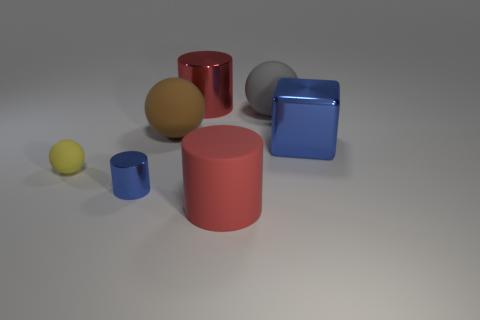There is a matte cylinder; how many small cylinders are behind it?
Your answer should be compact. 1. Is there a small shiny cylinder that has the same color as the shiny cube?
Ensure brevity in your answer.  Yes. There is a blue object that is the same size as the red metal object; what shape is it?
Make the answer very short. Cube. How many blue objects are big objects or tiny spheres?
Give a very brief answer. 1. How many objects are the same size as the yellow rubber ball?
Offer a very short reply. 1. What shape is the small object that is the same color as the block?
Offer a terse response. Cylinder. How many objects are large brown objects or matte spheres behind the tiny yellow rubber ball?
Give a very brief answer. 2. There is a red object in front of the big red shiny cylinder; is it the same size as the blue thing that is on the right side of the red rubber thing?
Give a very brief answer. Yes. What number of big gray things have the same shape as the brown matte object?
Provide a succinct answer. 1. What is the shape of the large red thing that is made of the same material as the yellow object?
Give a very brief answer. Cylinder. 